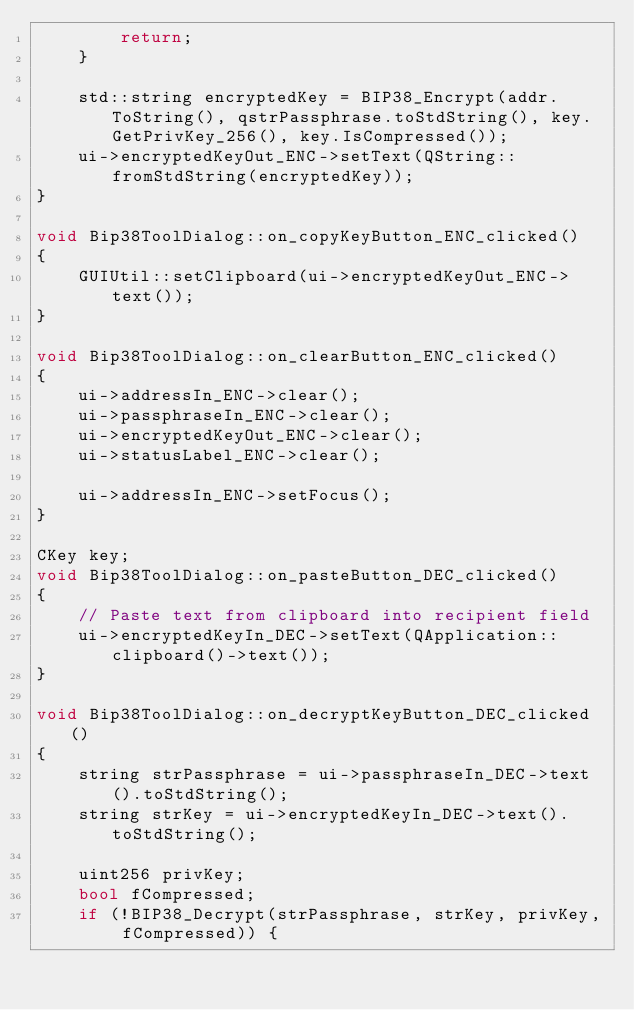<code> <loc_0><loc_0><loc_500><loc_500><_C++_>        return;
    }

    std::string encryptedKey = BIP38_Encrypt(addr.ToString(), qstrPassphrase.toStdString(), key.GetPrivKey_256(), key.IsCompressed());
    ui->encryptedKeyOut_ENC->setText(QString::fromStdString(encryptedKey));
}

void Bip38ToolDialog::on_copyKeyButton_ENC_clicked()
{
    GUIUtil::setClipboard(ui->encryptedKeyOut_ENC->text());
}

void Bip38ToolDialog::on_clearButton_ENC_clicked()
{
    ui->addressIn_ENC->clear();
    ui->passphraseIn_ENC->clear();
    ui->encryptedKeyOut_ENC->clear();
    ui->statusLabel_ENC->clear();

    ui->addressIn_ENC->setFocus();
}

CKey key;
void Bip38ToolDialog::on_pasteButton_DEC_clicked()
{
    // Paste text from clipboard into recipient field
    ui->encryptedKeyIn_DEC->setText(QApplication::clipboard()->text());
}

void Bip38ToolDialog::on_decryptKeyButton_DEC_clicked()
{
    string strPassphrase = ui->passphraseIn_DEC->text().toStdString();
    string strKey = ui->encryptedKeyIn_DEC->text().toStdString();

    uint256 privKey;
    bool fCompressed;
    if (!BIP38_Decrypt(strPassphrase, strKey, privKey, fCompressed)) {</code> 